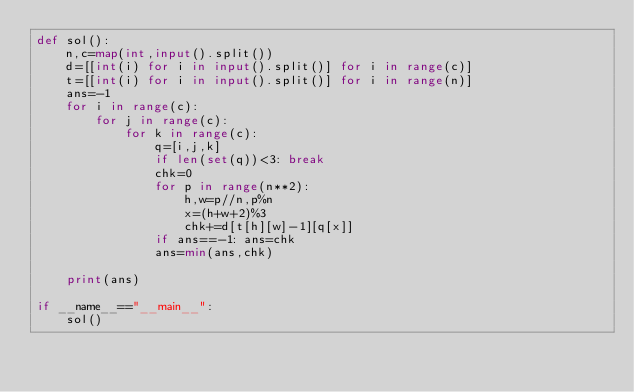<code> <loc_0><loc_0><loc_500><loc_500><_Python_>def sol():
    n,c=map(int,input().split())
    d=[[int(i) for i in input().split()] for i in range(c)]
    t=[[int(i) for i in input().split()] for i in range(n)]
    ans=-1
    for i in range(c):
        for j in range(c):
            for k in range(c):
                q=[i,j,k]
                if len(set(q))<3: break
                chk=0
                for p in range(n**2):
                    h,w=p//n,p%n
                    x=(h+w+2)%3
                    chk+=d[t[h][w]-1][q[x]]
                if ans==-1: ans=chk
                ans=min(ans,chk)

    print(ans)

if __name__=="__main__":
    sol()
</code> 